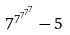Convert formula to latex. <formula><loc_0><loc_0><loc_500><loc_500>7 ^ { 7 ^ { 7 ^ { 7 ^ { 7 } } } } - 5</formula> 